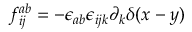Convert formula to latex. <formula><loc_0><loc_0><loc_500><loc_500>f _ { i j } ^ { a b } = - { \epsilon _ { a b } } { \epsilon _ { i j k } } \partial _ { k } \delta ( x - y )</formula> 